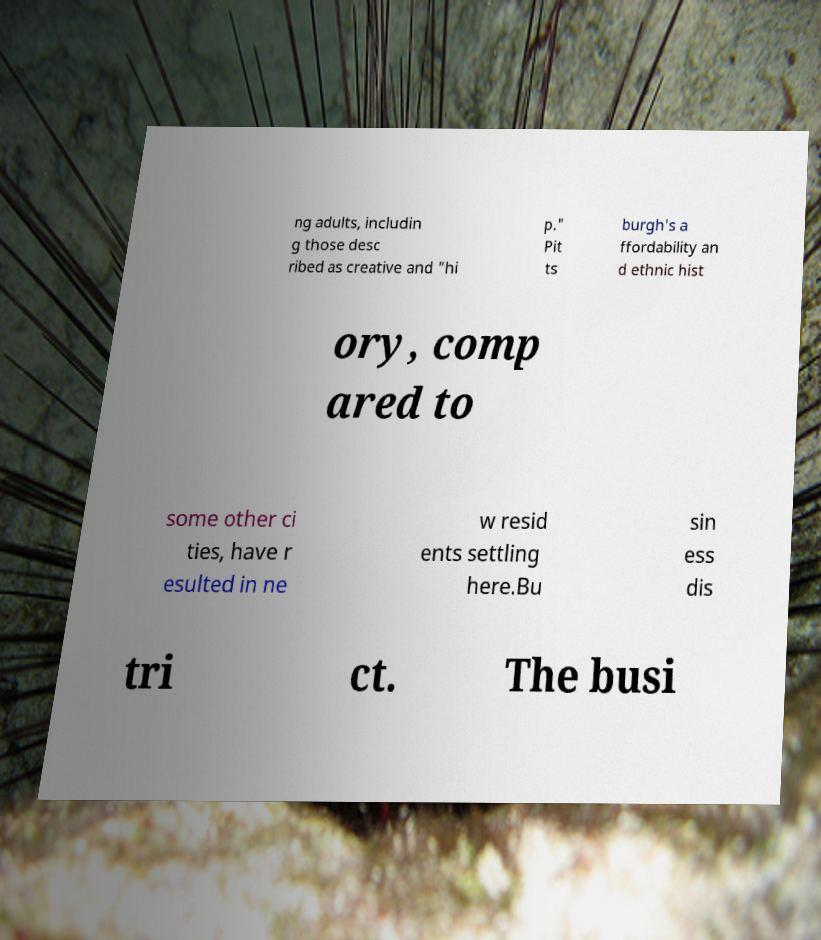Please read and relay the text visible in this image. What does it say? ng adults, includin g those desc ribed as creative and "hi p." Pit ts burgh's a ffordability an d ethnic hist ory, comp ared to some other ci ties, have r esulted in ne w resid ents settling here.Bu sin ess dis tri ct. The busi 